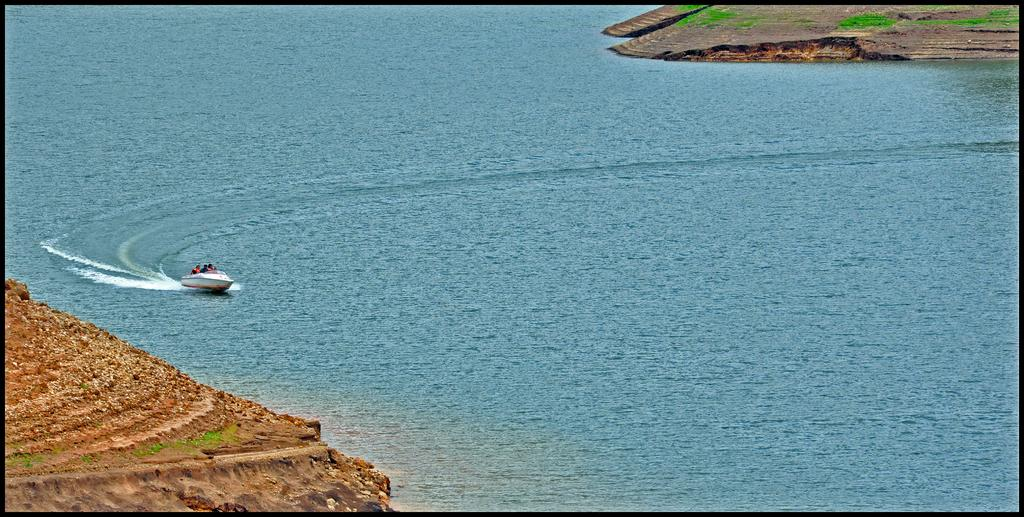What is the main subject in the water in the image? There is a boat in the water in the image. What can be seen on the left side of the image? There is land on the left side of the image. Who is in the boat? There are people in the boat. What type of vegetation is on the right top of the image? There is land with grass on the right top of the image. What type of bait is being used by the people in the boat? There is no mention of bait or fishing in the image, so it cannot be determined what type of bait might be used. 